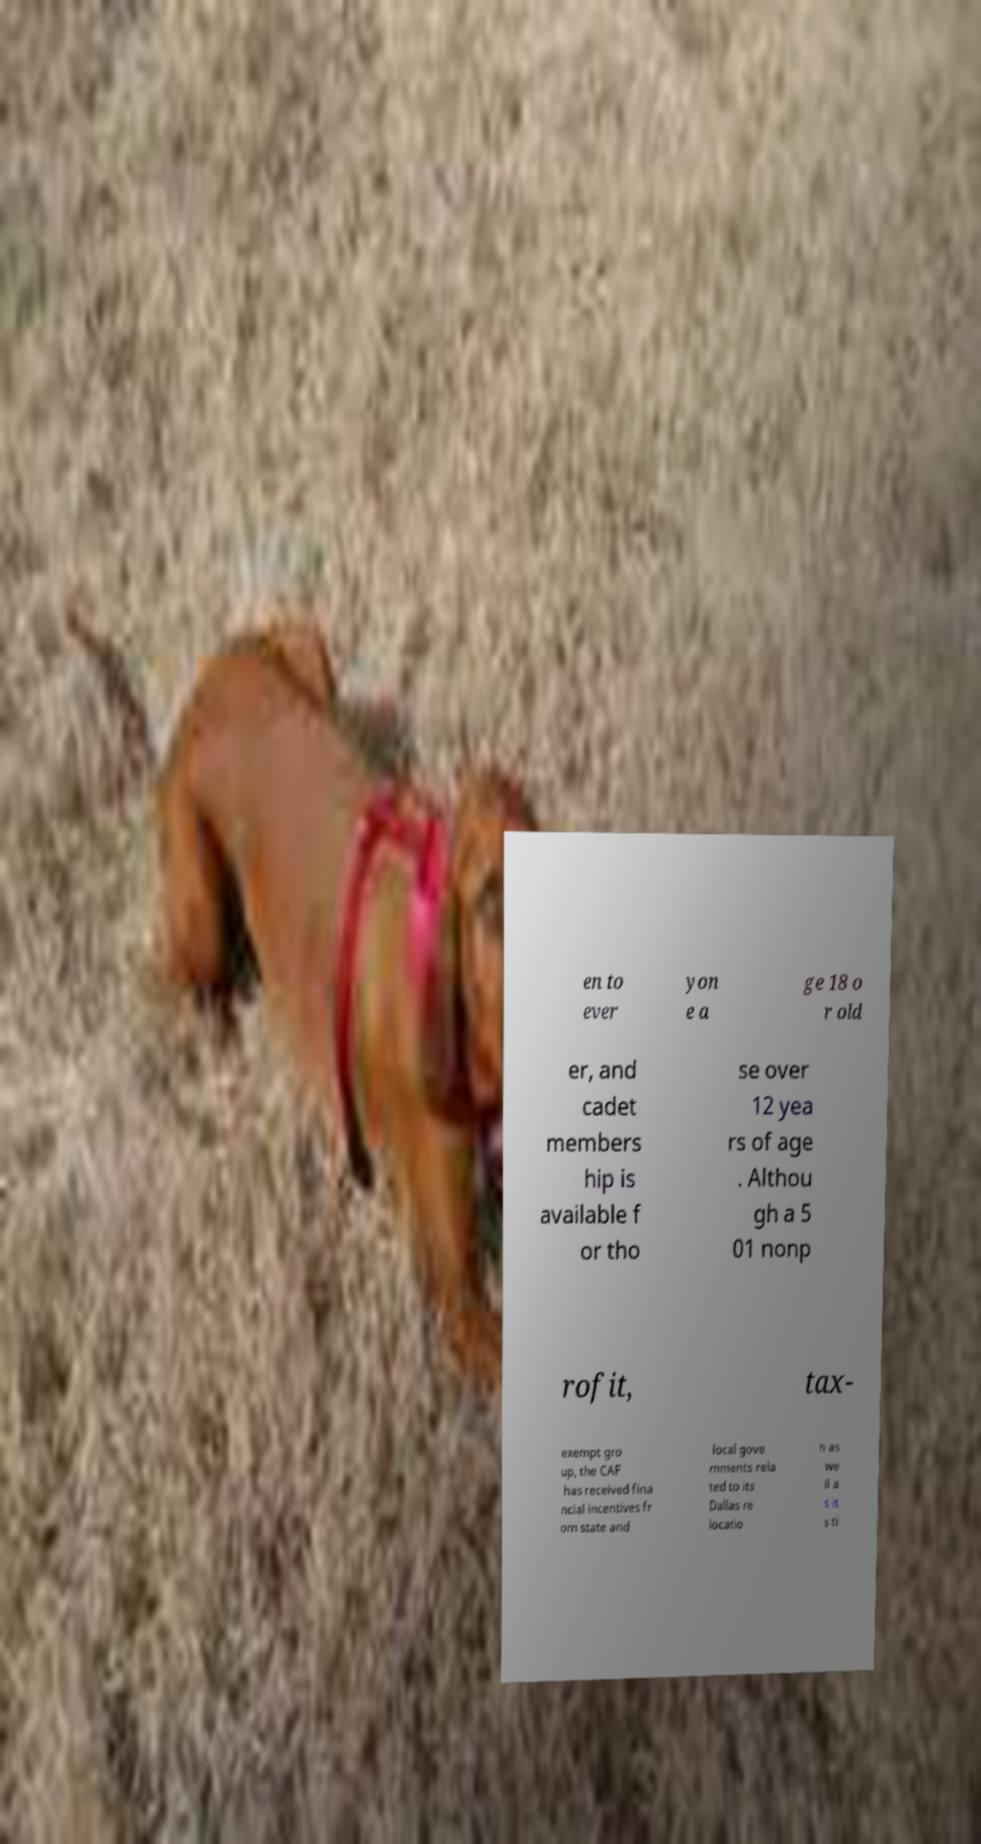For documentation purposes, I need the text within this image transcribed. Could you provide that? en to ever yon e a ge 18 o r old er, and cadet members hip is available f or tho se over 12 yea rs of age . Althou gh a 5 01 nonp rofit, tax- exempt gro up, the CAF has received fina ncial incentives fr om state and local gove rnments rela ted to its Dallas re locatio n as we ll a s it s ti 